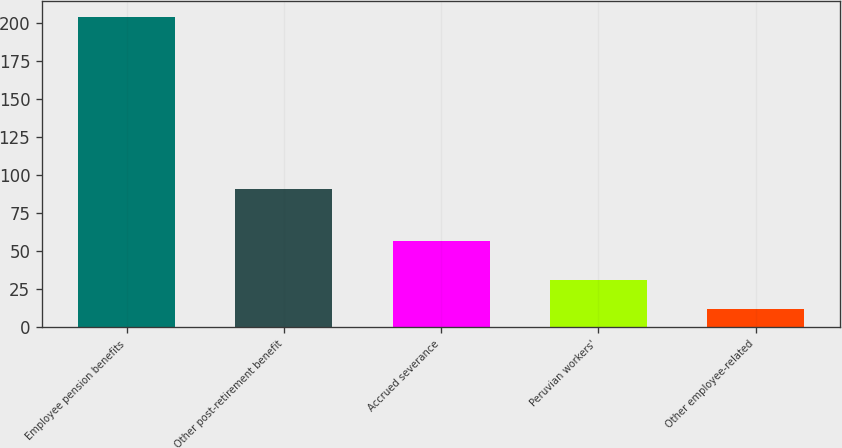Convert chart to OTSL. <chart><loc_0><loc_0><loc_500><loc_500><bar_chart><fcel>Employee pension benefits<fcel>Other post-retirement benefit<fcel>Accrued severance<fcel>Peruvian workers'<fcel>Other employee-related<nl><fcel>204<fcel>91<fcel>57<fcel>31.2<fcel>12<nl></chart> 